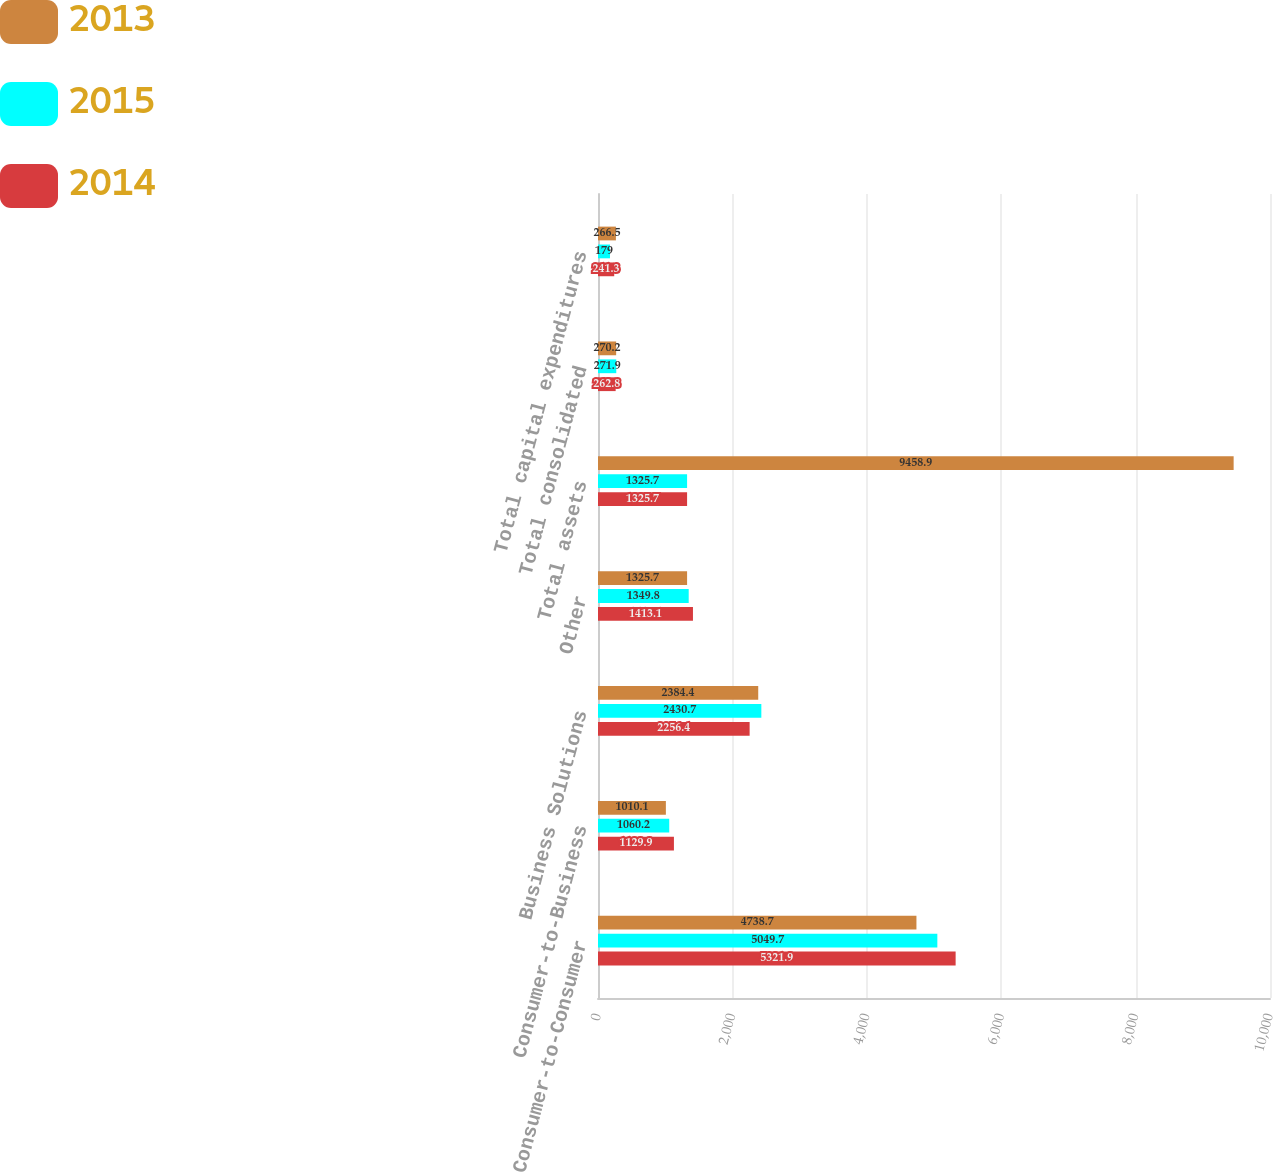Convert chart to OTSL. <chart><loc_0><loc_0><loc_500><loc_500><stacked_bar_chart><ecel><fcel>Consumer-to-Consumer<fcel>Consumer-to-Business<fcel>Business Solutions<fcel>Other<fcel>Total assets<fcel>Total consolidated<fcel>Total capital expenditures<nl><fcel>2013<fcel>4738.7<fcel>1010.1<fcel>2384.4<fcel>1325.7<fcel>9458.9<fcel>270.2<fcel>266.5<nl><fcel>2015<fcel>5049.7<fcel>1060.2<fcel>2430.7<fcel>1349.8<fcel>1325.7<fcel>271.9<fcel>179<nl><fcel>2014<fcel>5321.9<fcel>1129.9<fcel>2256.4<fcel>1413.1<fcel>1325.7<fcel>262.8<fcel>241.3<nl></chart> 